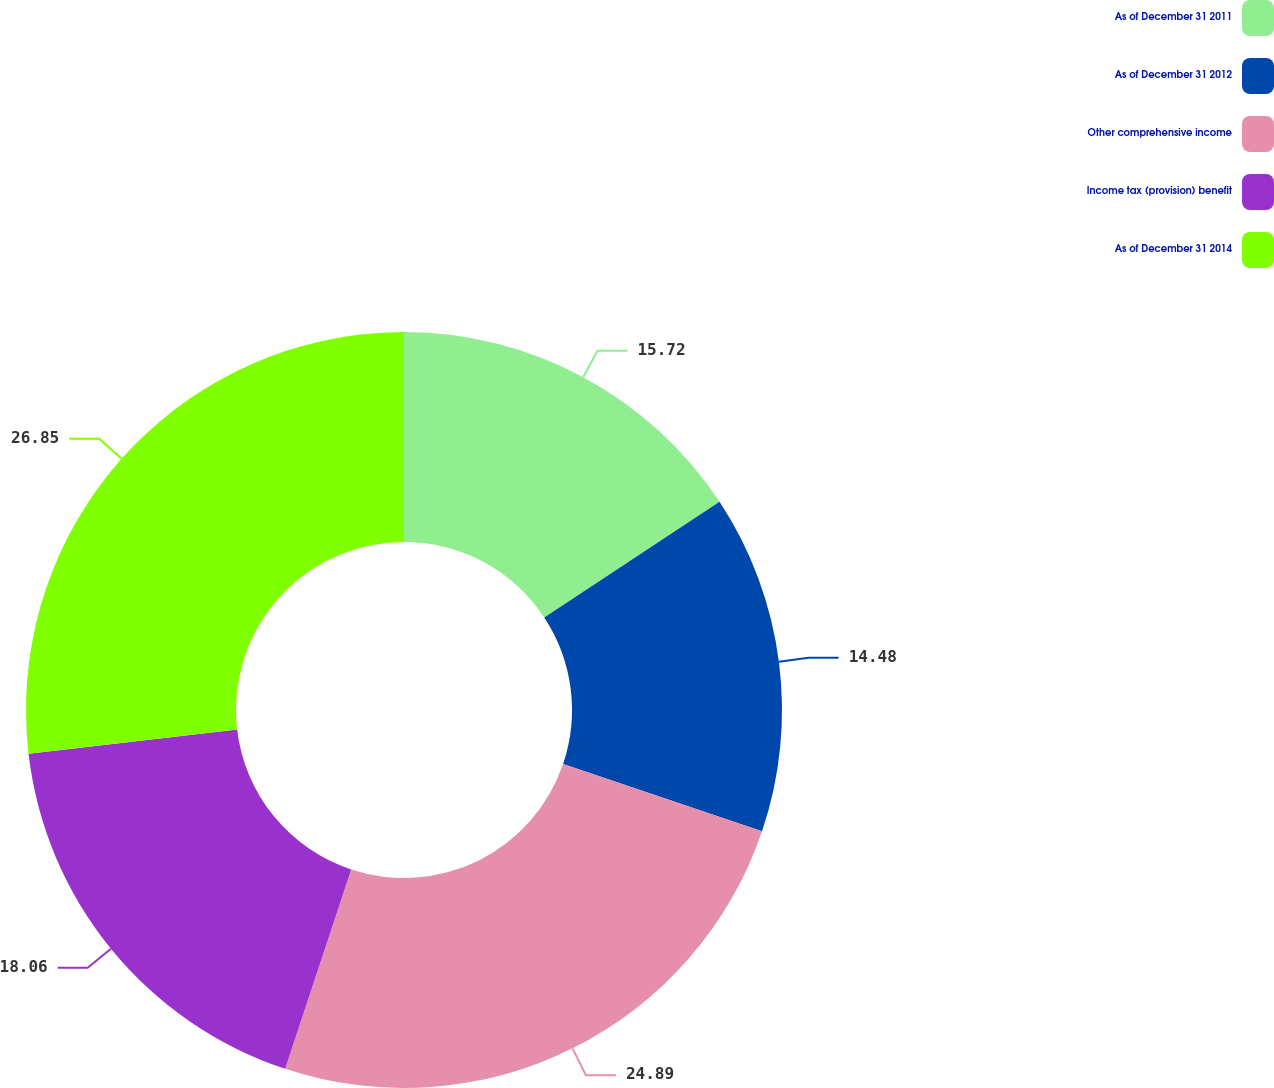Convert chart. <chart><loc_0><loc_0><loc_500><loc_500><pie_chart><fcel>As of December 31 2011<fcel>As of December 31 2012<fcel>Other comprehensive income<fcel>Income tax (provision) benefit<fcel>As of December 31 2014<nl><fcel>15.72%<fcel>14.48%<fcel>24.89%<fcel>18.06%<fcel>26.85%<nl></chart> 